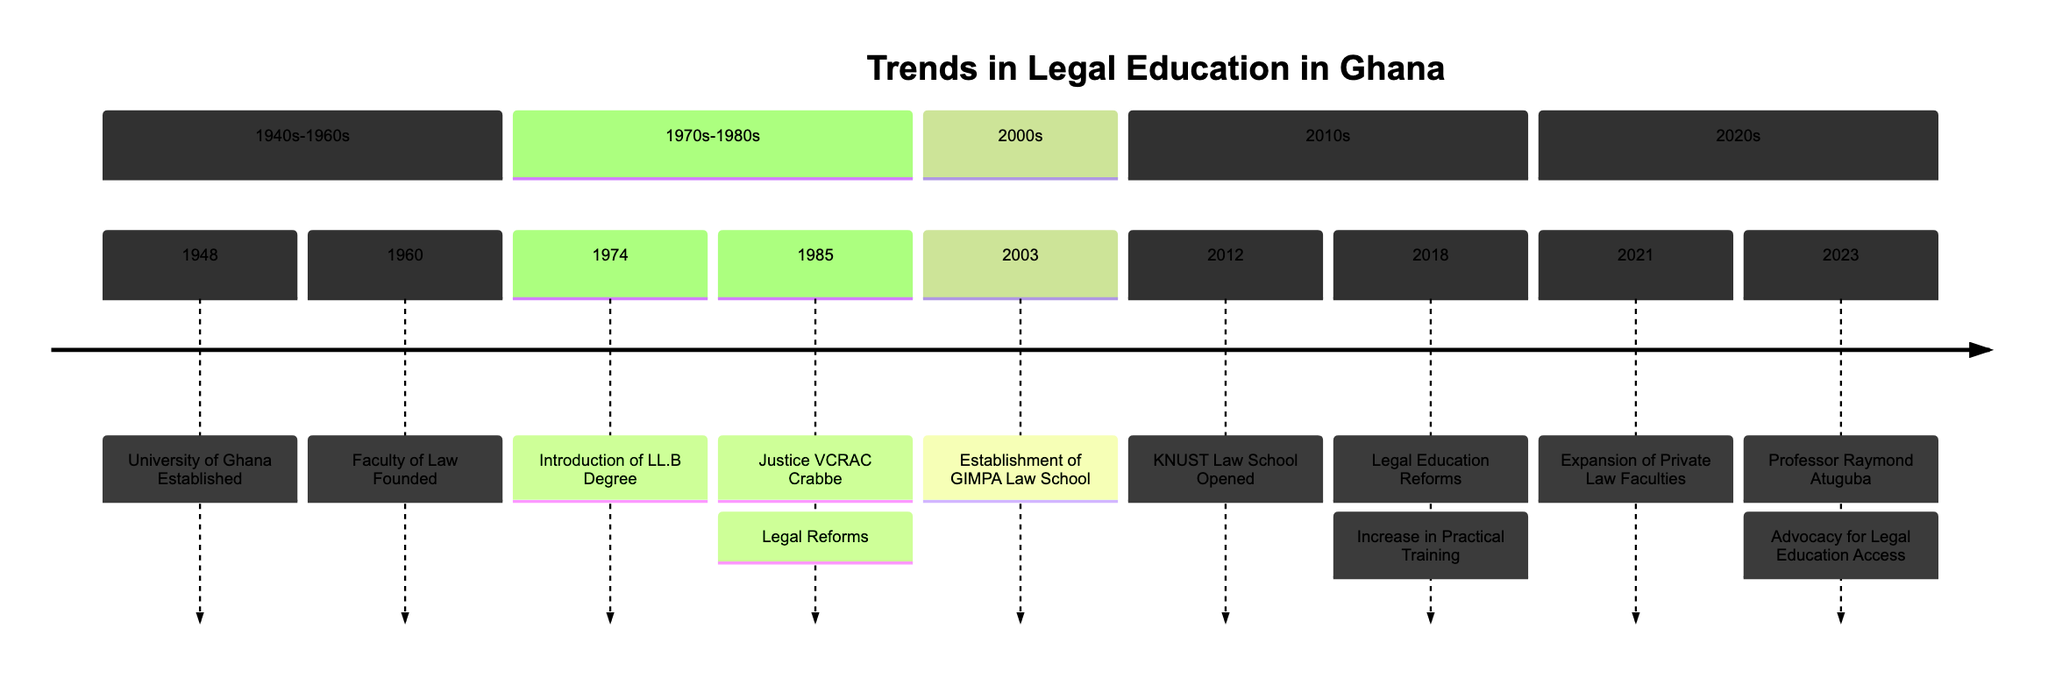What year was the University of Ghana established? The diagram shows a timeline indicating that the University of Ghana was established in 1948.
Answer: 1948 What significant development occurred in 1960? According to the timeline, the significant development in 1960 was the founding of the Faculty of Law.
Answer: Faculty of Law Founded How many milestones are listed in the 1970s-1980s section? By counting the milestones in the 1970s-1980s section of the diagram, there are two milestones listed: the introduction of the LL.B Degree in 1974 and Justice VCRAC Crabbe's contributions in 1985.
Answer: 2 What major legal reform happened in 2018? The diagram specifies that in 2018, there were legal education reforms that emphasized an increase in practical training.
Answer: Increase in Practical Training Who advocated for legal education access in 2023? The diagram identifies Professor Raymond Atuguba as the advocate for legal education access in 2023.
Answer: Professor Raymond Atuguba What does the timeline depict specifically regarding legal education? The timeline depicts the evolution and major milestones in legal education in Ghana, focusing on the establishment of law schools and contributions of influential professors.
Answer: Evolution and major milestones Which law school was established in 2003? The timeline indicates that the GIMPA Law School was established in 2003.
Answer: GIMPA Law School In which section of the timeline does the introduction of the LL.B Degree fall? The introduction of the LL.B Degree is placed in the 1970s-1980s section of the timeline, indicating it was a milestone from that period.
Answer: 1970s-1980s What theme is used for the timeline diagram? The diagram uses a 'forest' theme as indicated at the initialization for visual presentation.
Answer: Forest 